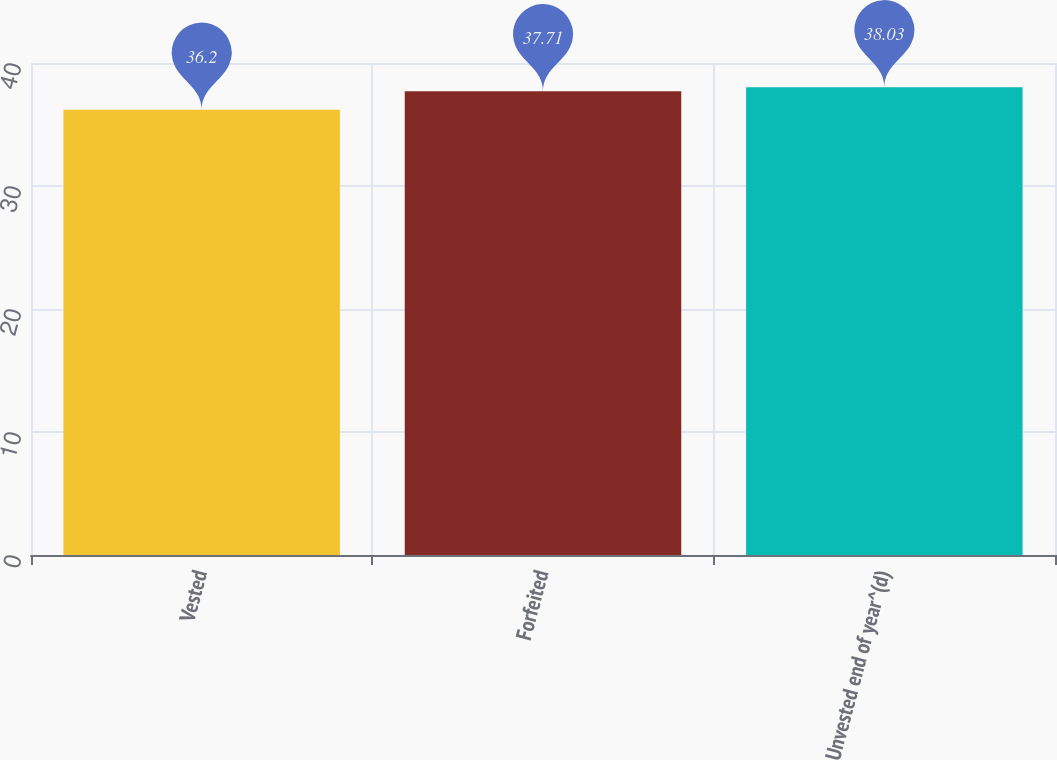Convert chart to OTSL. <chart><loc_0><loc_0><loc_500><loc_500><bar_chart><fcel>Vested<fcel>Forfeited<fcel>Unvested end of year^(d)<nl><fcel>36.2<fcel>37.71<fcel>38.03<nl></chart> 